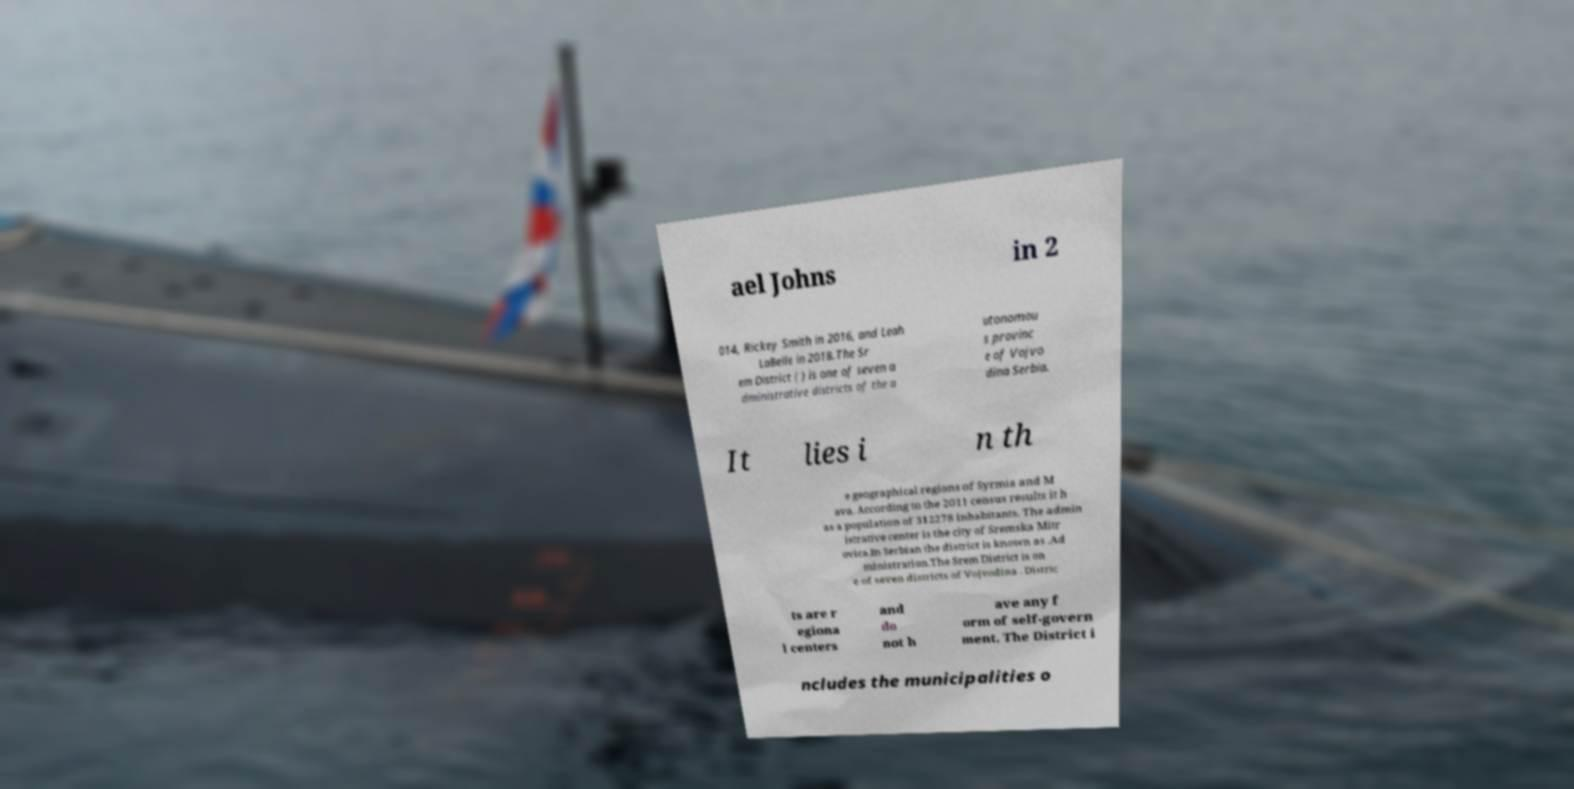Please read and relay the text visible in this image. What does it say? ael Johns in 2 014, Rickey Smith in 2016, and Leah LaBelle in 2018.The Sr em District ( ) is one of seven a dministrative districts of the a utonomou s provinc e of Vojvo dina Serbia. It lies i n th e geographical regions of Syrmia and M ava. According to the 2011 census results it h as a population of 312278 inhabitants. The admin istrative center is the city of Sremska Mitr ovica.In Serbian the district is known as .Ad ministration.The Srem District is on e of seven districts of Vojvodina . Distric ts are r egiona l centers and do not h ave any f orm of self-govern ment. The District i ncludes the municipalities o 